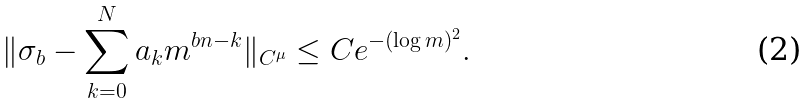<formula> <loc_0><loc_0><loc_500><loc_500>\| \sigma _ { b } - \sum _ { k = 0 } ^ { N } a _ { k } m ^ { b n - k } \| _ { C ^ { \mu } } \leq C e ^ { - ( \log m ) ^ { 2 } } .</formula> 